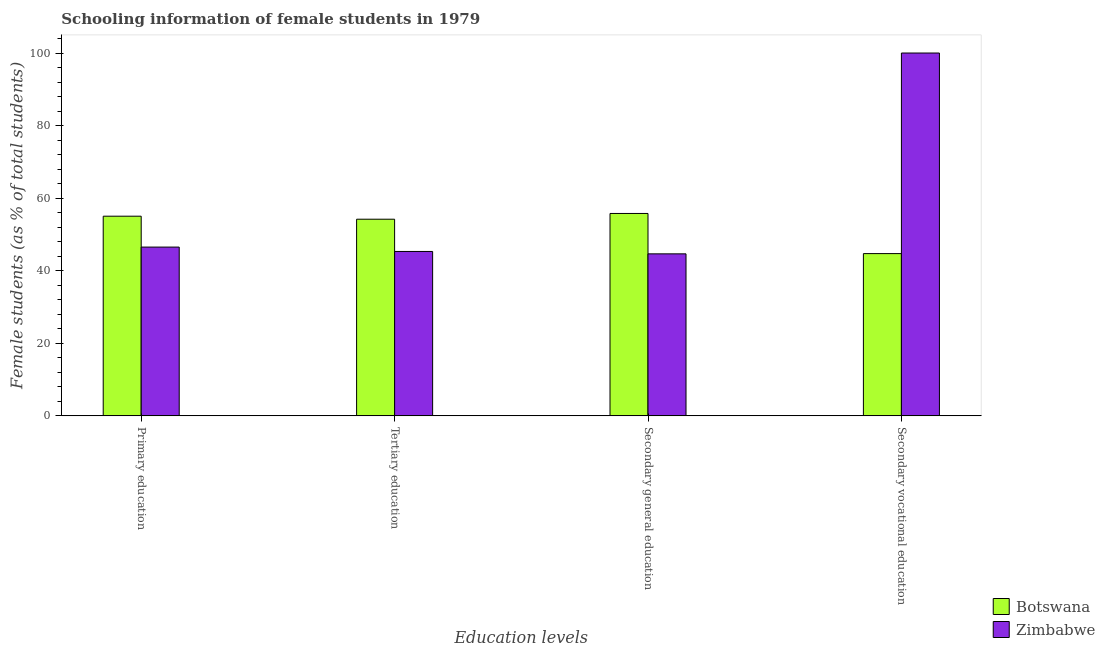How many groups of bars are there?
Your response must be concise. 4. Are the number of bars per tick equal to the number of legend labels?
Provide a short and direct response. Yes. What is the label of the 4th group of bars from the left?
Offer a very short reply. Secondary vocational education. What is the percentage of female students in tertiary education in Zimbabwe?
Your answer should be compact. 45.31. Across all countries, what is the maximum percentage of female students in secondary education?
Offer a very short reply. 55.78. Across all countries, what is the minimum percentage of female students in tertiary education?
Make the answer very short. 45.31. In which country was the percentage of female students in tertiary education maximum?
Offer a terse response. Botswana. In which country was the percentage of female students in secondary education minimum?
Your answer should be compact. Zimbabwe. What is the total percentage of female students in tertiary education in the graph?
Make the answer very short. 99.51. What is the difference between the percentage of female students in secondary education in Botswana and that in Zimbabwe?
Your answer should be very brief. 11.13. What is the difference between the percentage of female students in primary education in Botswana and the percentage of female students in secondary vocational education in Zimbabwe?
Ensure brevity in your answer.  -44.97. What is the average percentage of female students in primary education per country?
Ensure brevity in your answer.  50.77. What is the difference between the percentage of female students in secondary education and percentage of female students in secondary vocational education in Botswana?
Keep it short and to the point. 11.07. In how many countries, is the percentage of female students in secondary vocational education greater than 56 %?
Give a very brief answer. 1. What is the ratio of the percentage of female students in tertiary education in Botswana to that in Zimbabwe?
Your response must be concise. 1.2. Is the percentage of female students in tertiary education in Zimbabwe less than that in Botswana?
Ensure brevity in your answer.  Yes. What is the difference between the highest and the second highest percentage of female students in secondary education?
Give a very brief answer. 11.13. What is the difference between the highest and the lowest percentage of female students in secondary vocational education?
Keep it short and to the point. 55.28. In how many countries, is the percentage of female students in primary education greater than the average percentage of female students in primary education taken over all countries?
Your answer should be compact. 1. Is the sum of the percentage of female students in secondary education in Zimbabwe and Botswana greater than the maximum percentage of female students in secondary vocational education across all countries?
Provide a short and direct response. Yes. Is it the case that in every country, the sum of the percentage of female students in secondary education and percentage of female students in tertiary education is greater than the sum of percentage of female students in secondary vocational education and percentage of female students in primary education?
Offer a very short reply. No. What does the 1st bar from the left in Primary education represents?
Your answer should be compact. Botswana. What does the 2nd bar from the right in Secondary vocational education represents?
Your answer should be very brief. Botswana. How many bars are there?
Offer a terse response. 8. Are all the bars in the graph horizontal?
Keep it short and to the point. No. How many countries are there in the graph?
Provide a succinct answer. 2. What is the difference between two consecutive major ticks on the Y-axis?
Keep it short and to the point. 20. How are the legend labels stacked?
Make the answer very short. Vertical. What is the title of the graph?
Your answer should be compact. Schooling information of female students in 1979. What is the label or title of the X-axis?
Provide a short and direct response. Education levels. What is the label or title of the Y-axis?
Your answer should be very brief. Female students (as % of total students). What is the Female students (as % of total students) of Botswana in Primary education?
Ensure brevity in your answer.  55.03. What is the Female students (as % of total students) in Zimbabwe in Primary education?
Provide a succinct answer. 46.51. What is the Female students (as % of total students) of Botswana in Tertiary education?
Make the answer very short. 54.2. What is the Female students (as % of total students) of Zimbabwe in Tertiary education?
Your answer should be compact. 45.31. What is the Female students (as % of total students) of Botswana in Secondary general education?
Ensure brevity in your answer.  55.78. What is the Female students (as % of total students) in Zimbabwe in Secondary general education?
Your answer should be compact. 44.65. What is the Female students (as % of total students) in Botswana in Secondary vocational education?
Ensure brevity in your answer.  44.72. What is the Female students (as % of total students) of Zimbabwe in Secondary vocational education?
Make the answer very short. 100. Across all Education levels, what is the maximum Female students (as % of total students) of Botswana?
Ensure brevity in your answer.  55.78. Across all Education levels, what is the minimum Female students (as % of total students) in Botswana?
Keep it short and to the point. 44.72. Across all Education levels, what is the minimum Female students (as % of total students) of Zimbabwe?
Provide a short and direct response. 44.65. What is the total Female students (as % of total students) of Botswana in the graph?
Your answer should be very brief. 209.73. What is the total Female students (as % of total students) of Zimbabwe in the graph?
Provide a short and direct response. 236.48. What is the difference between the Female students (as % of total students) of Botswana in Primary education and that in Tertiary education?
Make the answer very short. 0.83. What is the difference between the Female students (as % of total students) in Zimbabwe in Primary education and that in Tertiary education?
Provide a succinct answer. 1.21. What is the difference between the Female students (as % of total students) in Botswana in Primary education and that in Secondary general education?
Offer a terse response. -0.76. What is the difference between the Female students (as % of total students) in Zimbabwe in Primary education and that in Secondary general education?
Offer a very short reply. 1.86. What is the difference between the Female students (as % of total students) of Botswana in Primary education and that in Secondary vocational education?
Your answer should be very brief. 10.31. What is the difference between the Female students (as % of total students) in Zimbabwe in Primary education and that in Secondary vocational education?
Keep it short and to the point. -53.49. What is the difference between the Female students (as % of total students) of Botswana in Tertiary education and that in Secondary general education?
Your answer should be very brief. -1.59. What is the difference between the Female students (as % of total students) of Zimbabwe in Tertiary education and that in Secondary general education?
Provide a succinct answer. 0.66. What is the difference between the Female students (as % of total students) in Botswana in Tertiary education and that in Secondary vocational education?
Your answer should be compact. 9.48. What is the difference between the Female students (as % of total students) of Zimbabwe in Tertiary education and that in Secondary vocational education?
Offer a terse response. -54.69. What is the difference between the Female students (as % of total students) in Botswana in Secondary general education and that in Secondary vocational education?
Offer a terse response. 11.07. What is the difference between the Female students (as % of total students) of Zimbabwe in Secondary general education and that in Secondary vocational education?
Your answer should be very brief. -55.35. What is the difference between the Female students (as % of total students) in Botswana in Primary education and the Female students (as % of total students) in Zimbabwe in Tertiary education?
Your response must be concise. 9.72. What is the difference between the Female students (as % of total students) of Botswana in Primary education and the Female students (as % of total students) of Zimbabwe in Secondary general education?
Provide a succinct answer. 10.37. What is the difference between the Female students (as % of total students) of Botswana in Primary education and the Female students (as % of total students) of Zimbabwe in Secondary vocational education?
Provide a succinct answer. -44.97. What is the difference between the Female students (as % of total students) in Botswana in Tertiary education and the Female students (as % of total students) in Zimbabwe in Secondary general education?
Provide a short and direct response. 9.54. What is the difference between the Female students (as % of total students) in Botswana in Tertiary education and the Female students (as % of total students) in Zimbabwe in Secondary vocational education?
Offer a very short reply. -45.8. What is the difference between the Female students (as % of total students) of Botswana in Secondary general education and the Female students (as % of total students) of Zimbabwe in Secondary vocational education?
Your response must be concise. -44.22. What is the average Female students (as % of total students) in Botswana per Education levels?
Offer a very short reply. 52.43. What is the average Female students (as % of total students) of Zimbabwe per Education levels?
Ensure brevity in your answer.  59.12. What is the difference between the Female students (as % of total students) in Botswana and Female students (as % of total students) in Zimbabwe in Primary education?
Make the answer very short. 8.51. What is the difference between the Female students (as % of total students) in Botswana and Female students (as % of total students) in Zimbabwe in Tertiary education?
Your response must be concise. 8.89. What is the difference between the Female students (as % of total students) of Botswana and Female students (as % of total students) of Zimbabwe in Secondary general education?
Your response must be concise. 11.13. What is the difference between the Female students (as % of total students) of Botswana and Female students (as % of total students) of Zimbabwe in Secondary vocational education?
Provide a short and direct response. -55.28. What is the ratio of the Female students (as % of total students) in Botswana in Primary education to that in Tertiary education?
Provide a short and direct response. 1.02. What is the ratio of the Female students (as % of total students) in Zimbabwe in Primary education to that in Tertiary education?
Keep it short and to the point. 1.03. What is the ratio of the Female students (as % of total students) in Botswana in Primary education to that in Secondary general education?
Offer a terse response. 0.99. What is the ratio of the Female students (as % of total students) of Zimbabwe in Primary education to that in Secondary general education?
Provide a succinct answer. 1.04. What is the ratio of the Female students (as % of total students) of Botswana in Primary education to that in Secondary vocational education?
Offer a very short reply. 1.23. What is the ratio of the Female students (as % of total students) in Zimbabwe in Primary education to that in Secondary vocational education?
Ensure brevity in your answer.  0.47. What is the ratio of the Female students (as % of total students) of Botswana in Tertiary education to that in Secondary general education?
Your answer should be compact. 0.97. What is the ratio of the Female students (as % of total students) in Zimbabwe in Tertiary education to that in Secondary general education?
Give a very brief answer. 1.01. What is the ratio of the Female students (as % of total students) of Botswana in Tertiary education to that in Secondary vocational education?
Your answer should be compact. 1.21. What is the ratio of the Female students (as % of total students) of Zimbabwe in Tertiary education to that in Secondary vocational education?
Your answer should be very brief. 0.45. What is the ratio of the Female students (as % of total students) in Botswana in Secondary general education to that in Secondary vocational education?
Keep it short and to the point. 1.25. What is the ratio of the Female students (as % of total students) in Zimbabwe in Secondary general education to that in Secondary vocational education?
Ensure brevity in your answer.  0.45. What is the difference between the highest and the second highest Female students (as % of total students) of Botswana?
Your answer should be very brief. 0.76. What is the difference between the highest and the second highest Female students (as % of total students) of Zimbabwe?
Your answer should be compact. 53.49. What is the difference between the highest and the lowest Female students (as % of total students) of Botswana?
Your response must be concise. 11.07. What is the difference between the highest and the lowest Female students (as % of total students) of Zimbabwe?
Offer a terse response. 55.35. 